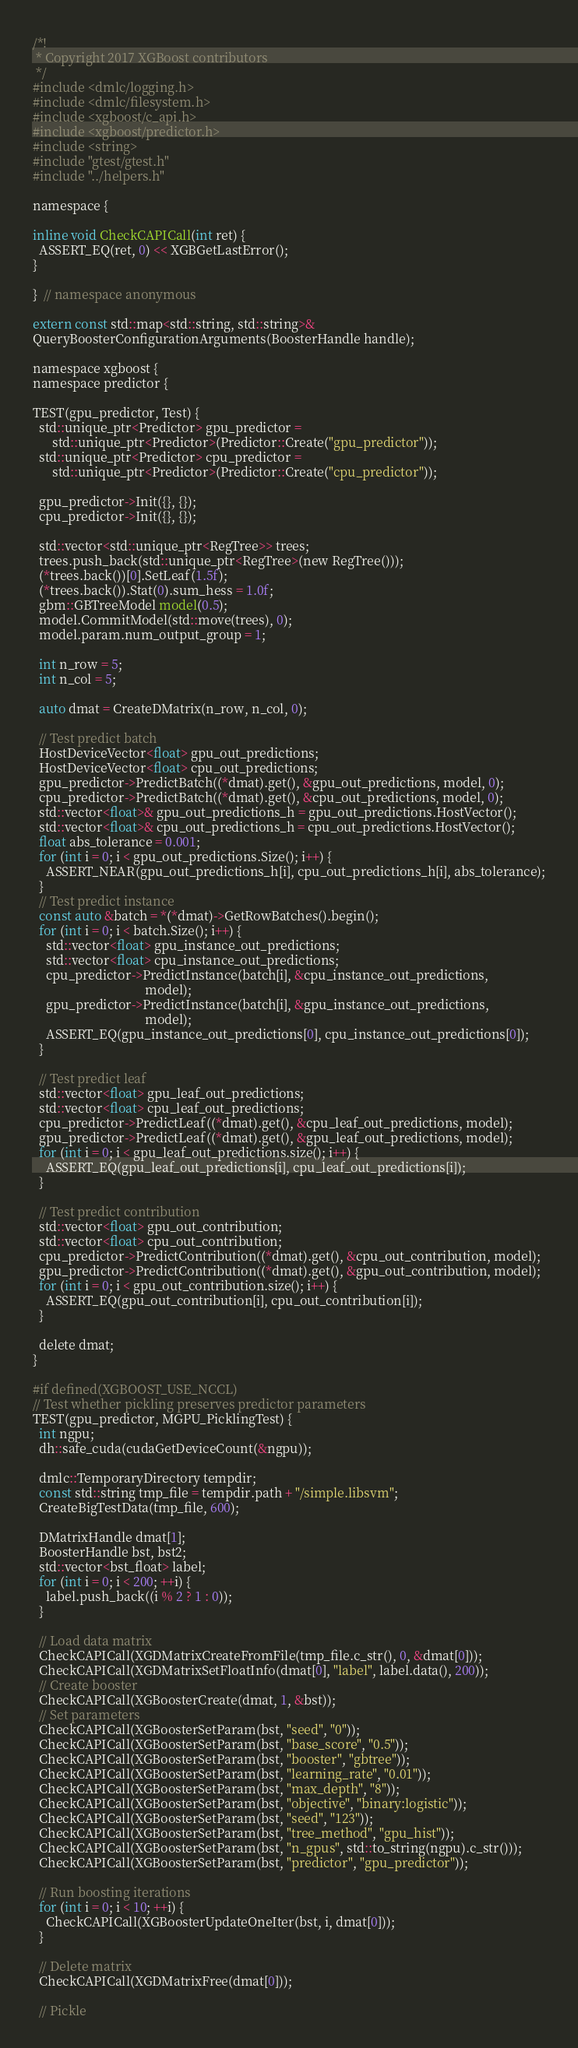Convert code to text. <code><loc_0><loc_0><loc_500><loc_500><_Cuda_>
/*!
 * Copyright 2017 XGBoost contributors
 */
#include <dmlc/logging.h>
#include <dmlc/filesystem.h>
#include <xgboost/c_api.h>
#include <xgboost/predictor.h>
#include <string>
#include "gtest/gtest.h"
#include "../helpers.h"

namespace {

inline void CheckCAPICall(int ret) {
  ASSERT_EQ(ret, 0) << XGBGetLastError();
}

}  // namespace anonymous

extern const std::map<std::string, std::string>&
QueryBoosterConfigurationArguments(BoosterHandle handle);

namespace xgboost {
namespace predictor {

TEST(gpu_predictor, Test) {
  std::unique_ptr<Predictor> gpu_predictor =
      std::unique_ptr<Predictor>(Predictor::Create("gpu_predictor"));
  std::unique_ptr<Predictor> cpu_predictor =
      std::unique_ptr<Predictor>(Predictor::Create("cpu_predictor"));

  gpu_predictor->Init({}, {});
  cpu_predictor->Init({}, {});

  std::vector<std::unique_ptr<RegTree>> trees;
  trees.push_back(std::unique_ptr<RegTree>(new RegTree()));
  (*trees.back())[0].SetLeaf(1.5f);
  (*trees.back()).Stat(0).sum_hess = 1.0f;
  gbm::GBTreeModel model(0.5);
  model.CommitModel(std::move(trees), 0);
  model.param.num_output_group = 1;

  int n_row = 5;
  int n_col = 5;

  auto dmat = CreateDMatrix(n_row, n_col, 0);

  // Test predict batch
  HostDeviceVector<float> gpu_out_predictions;
  HostDeviceVector<float> cpu_out_predictions;
  gpu_predictor->PredictBatch((*dmat).get(), &gpu_out_predictions, model, 0);
  cpu_predictor->PredictBatch((*dmat).get(), &cpu_out_predictions, model, 0);
  std::vector<float>& gpu_out_predictions_h = gpu_out_predictions.HostVector();
  std::vector<float>& cpu_out_predictions_h = cpu_out_predictions.HostVector();
  float abs_tolerance = 0.001;
  for (int i = 0; i < gpu_out_predictions.Size(); i++) {
    ASSERT_NEAR(gpu_out_predictions_h[i], cpu_out_predictions_h[i], abs_tolerance);
  }
  // Test predict instance
  const auto &batch = *(*dmat)->GetRowBatches().begin();
  for (int i = 0; i < batch.Size(); i++) {
    std::vector<float> gpu_instance_out_predictions;
    std::vector<float> cpu_instance_out_predictions;
    cpu_predictor->PredictInstance(batch[i], &cpu_instance_out_predictions,
                                   model);
    gpu_predictor->PredictInstance(batch[i], &gpu_instance_out_predictions,
                                   model);
    ASSERT_EQ(gpu_instance_out_predictions[0], cpu_instance_out_predictions[0]);
  }

  // Test predict leaf
  std::vector<float> gpu_leaf_out_predictions;
  std::vector<float> cpu_leaf_out_predictions;
  cpu_predictor->PredictLeaf((*dmat).get(), &cpu_leaf_out_predictions, model);
  gpu_predictor->PredictLeaf((*dmat).get(), &gpu_leaf_out_predictions, model);
  for (int i = 0; i < gpu_leaf_out_predictions.size(); i++) {
    ASSERT_EQ(gpu_leaf_out_predictions[i], cpu_leaf_out_predictions[i]);
  }

  // Test predict contribution
  std::vector<float> gpu_out_contribution;
  std::vector<float> cpu_out_contribution;
  cpu_predictor->PredictContribution((*dmat).get(), &cpu_out_contribution, model);
  gpu_predictor->PredictContribution((*dmat).get(), &gpu_out_contribution, model);
  for (int i = 0; i < gpu_out_contribution.size(); i++) {
    ASSERT_EQ(gpu_out_contribution[i], cpu_out_contribution[i]);
  }

  delete dmat;
}

#if defined(XGBOOST_USE_NCCL)
// Test whether pickling preserves predictor parameters
TEST(gpu_predictor, MGPU_PicklingTest) {
  int ngpu;
  dh::safe_cuda(cudaGetDeviceCount(&ngpu));

  dmlc::TemporaryDirectory tempdir;
  const std::string tmp_file = tempdir.path + "/simple.libsvm";
  CreateBigTestData(tmp_file, 600);

  DMatrixHandle dmat[1];
  BoosterHandle bst, bst2;
  std::vector<bst_float> label;
  for (int i = 0; i < 200; ++i) {
    label.push_back((i % 2 ? 1 : 0));
  }

  // Load data matrix
  CheckCAPICall(XGDMatrixCreateFromFile(tmp_file.c_str(), 0, &dmat[0]));
  CheckCAPICall(XGDMatrixSetFloatInfo(dmat[0], "label", label.data(), 200));
  // Create booster
  CheckCAPICall(XGBoosterCreate(dmat, 1, &bst));
  // Set parameters
  CheckCAPICall(XGBoosterSetParam(bst, "seed", "0"));
  CheckCAPICall(XGBoosterSetParam(bst, "base_score", "0.5"));
  CheckCAPICall(XGBoosterSetParam(bst, "booster", "gbtree"));
  CheckCAPICall(XGBoosterSetParam(bst, "learning_rate", "0.01"));
  CheckCAPICall(XGBoosterSetParam(bst, "max_depth", "8"));
  CheckCAPICall(XGBoosterSetParam(bst, "objective", "binary:logistic"));
  CheckCAPICall(XGBoosterSetParam(bst, "seed", "123"));
  CheckCAPICall(XGBoosterSetParam(bst, "tree_method", "gpu_hist"));
  CheckCAPICall(XGBoosterSetParam(bst, "n_gpus", std::to_string(ngpu).c_str()));
  CheckCAPICall(XGBoosterSetParam(bst, "predictor", "gpu_predictor"));

  // Run boosting iterations
  for (int i = 0; i < 10; ++i) {
    CheckCAPICall(XGBoosterUpdateOneIter(bst, i, dmat[0]));
  }

  // Delete matrix
  CheckCAPICall(XGDMatrixFree(dmat[0]));

  // Pickle</code> 